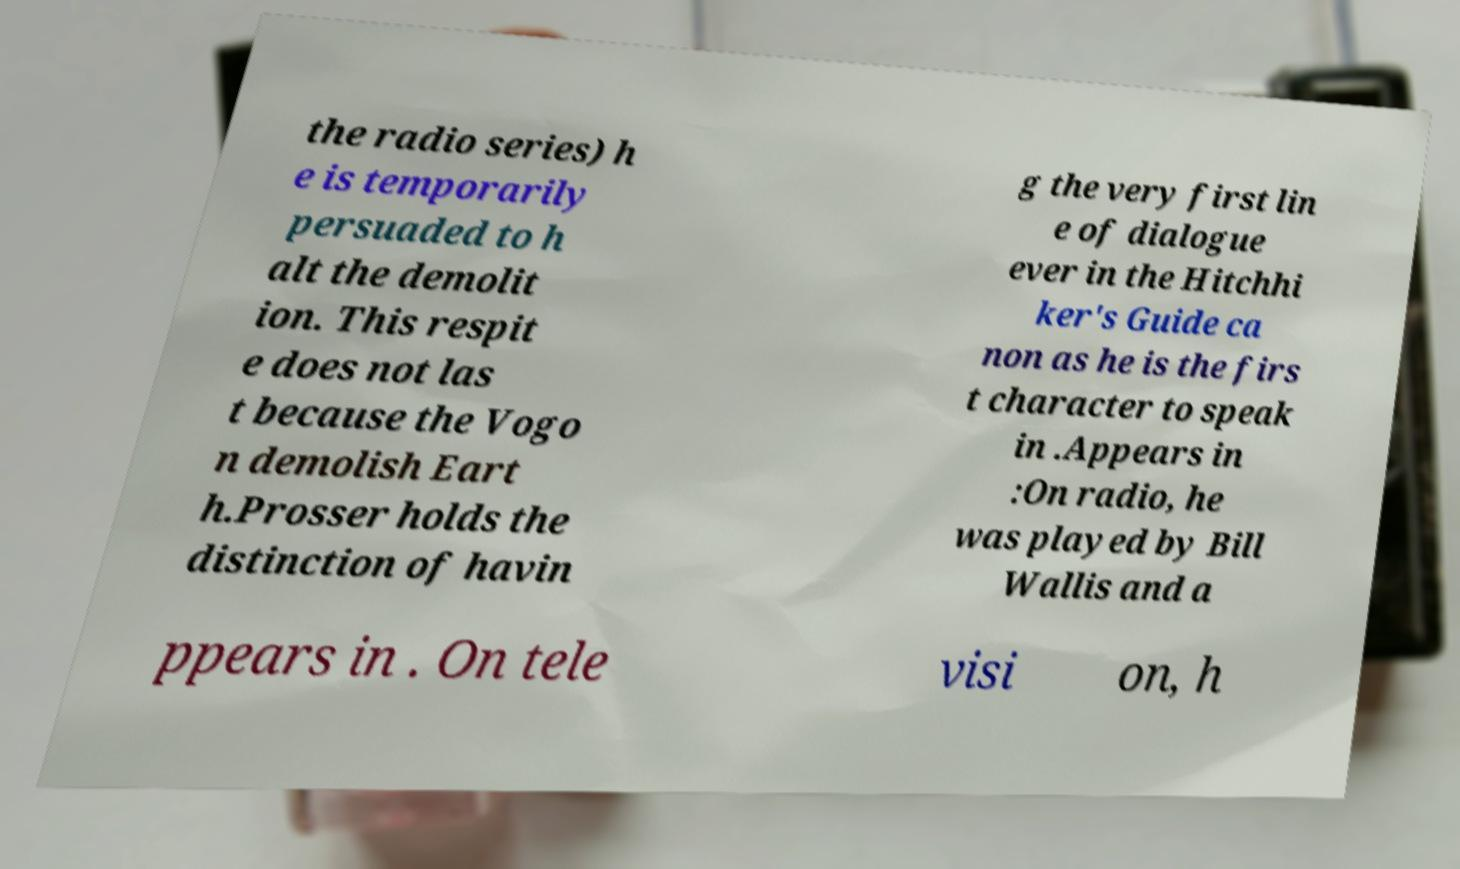For documentation purposes, I need the text within this image transcribed. Could you provide that? the radio series) h e is temporarily persuaded to h alt the demolit ion. This respit e does not las t because the Vogo n demolish Eart h.Prosser holds the distinction of havin g the very first lin e of dialogue ever in the Hitchhi ker's Guide ca non as he is the firs t character to speak in .Appears in :On radio, he was played by Bill Wallis and a ppears in . On tele visi on, h 